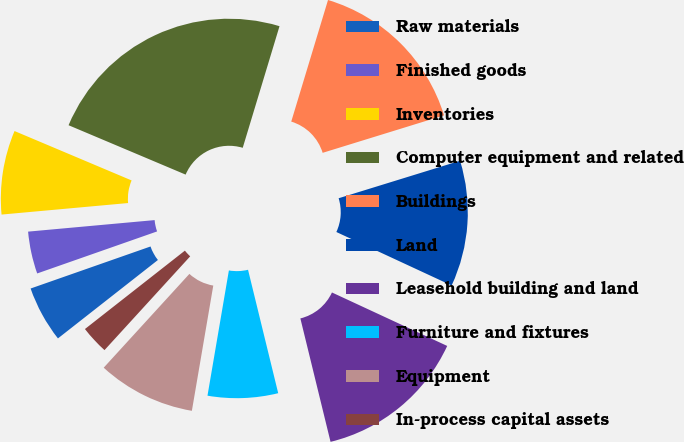Convert chart to OTSL. <chart><loc_0><loc_0><loc_500><loc_500><pie_chart><fcel>Raw materials<fcel>Finished goods<fcel>Inventories<fcel>Computer equipment and related<fcel>Buildings<fcel>Land<fcel>Leasehold building and land<fcel>Furniture and fixtures<fcel>Equipment<fcel>In-process capital assets<nl><fcel>5.22%<fcel>3.92%<fcel>7.8%<fcel>23.32%<fcel>15.56%<fcel>11.68%<fcel>14.27%<fcel>6.51%<fcel>9.09%<fcel>2.63%<nl></chart> 